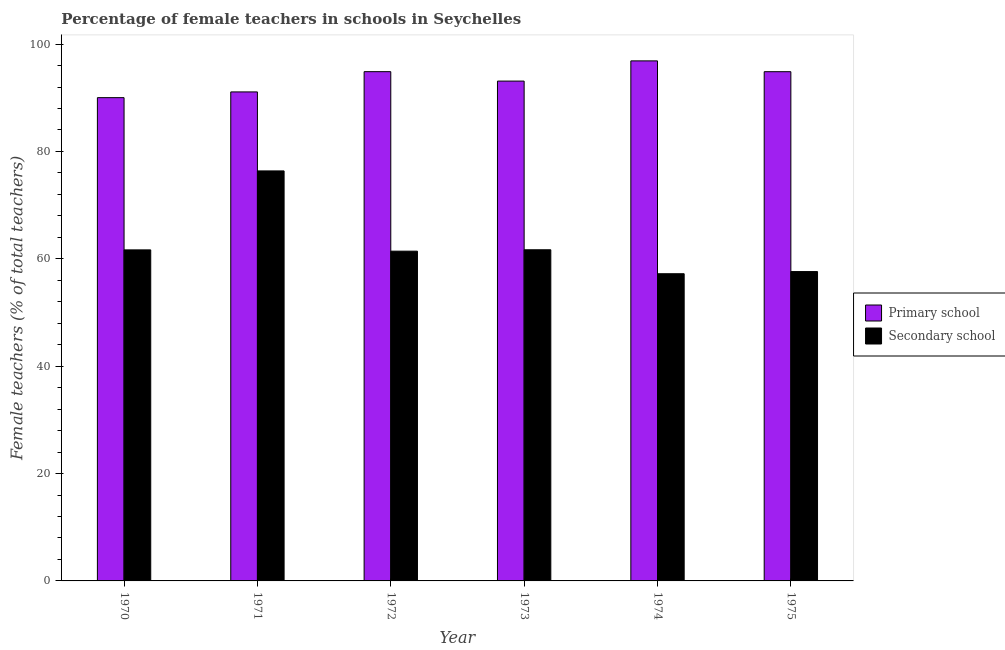How many different coloured bars are there?
Your response must be concise. 2. How many groups of bars are there?
Offer a terse response. 6. Are the number of bars on each tick of the X-axis equal?
Offer a very short reply. Yes. How many bars are there on the 3rd tick from the left?
Provide a succinct answer. 2. How many bars are there on the 2nd tick from the right?
Make the answer very short. 2. In how many cases, is the number of bars for a given year not equal to the number of legend labels?
Offer a terse response. 0. What is the percentage of female teachers in secondary schools in 1973?
Make the answer very short. 61.69. Across all years, what is the maximum percentage of female teachers in primary schools?
Your answer should be very brief. 96.88. Across all years, what is the minimum percentage of female teachers in primary schools?
Your response must be concise. 90.03. In which year was the percentage of female teachers in secondary schools minimum?
Keep it short and to the point. 1974. What is the total percentage of female teachers in secondary schools in the graph?
Provide a succinct answer. 376.01. What is the difference between the percentage of female teachers in secondary schools in 1970 and that in 1974?
Your response must be concise. 4.44. What is the difference between the percentage of female teachers in primary schools in 1975 and the percentage of female teachers in secondary schools in 1970?
Offer a terse response. 4.83. What is the average percentage of female teachers in secondary schools per year?
Give a very brief answer. 62.67. What is the ratio of the percentage of female teachers in secondary schools in 1972 to that in 1974?
Keep it short and to the point. 1.07. Is the difference between the percentage of female teachers in primary schools in 1973 and 1974 greater than the difference between the percentage of female teachers in secondary schools in 1973 and 1974?
Offer a very short reply. No. What is the difference between the highest and the second highest percentage of female teachers in primary schools?
Your answer should be compact. 2.01. What is the difference between the highest and the lowest percentage of female teachers in primary schools?
Make the answer very short. 6.85. What does the 1st bar from the left in 1974 represents?
Give a very brief answer. Primary school. What does the 2nd bar from the right in 1974 represents?
Your answer should be compact. Primary school. How many bars are there?
Your answer should be very brief. 12. How many years are there in the graph?
Offer a very short reply. 6. What is the difference between two consecutive major ticks on the Y-axis?
Make the answer very short. 20. Are the values on the major ticks of Y-axis written in scientific E-notation?
Keep it short and to the point. No. Where does the legend appear in the graph?
Provide a succinct answer. Center right. How are the legend labels stacked?
Give a very brief answer. Vertical. What is the title of the graph?
Make the answer very short. Percentage of female teachers in schools in Seychelles. Does "International Tourists" appear as one of the legend labels in the graph?
Give a very brief answer. No. What is the label or title of the X-axis?
Ensure brevity in your answer.  Year. What is the label or title of the Y-axis?
Provide a succinct answer. Female teachers (% of total teachers). What is the Female teachers (% of total teachers) of Primary school in 1970?
Offer a terse response. 90.03. What is the Female teachers (% of total teachers) in Secondary school in 1970?
Your answer should be compact. 61.67. What is the Female teachers (% of total teachers) of Primary school in 1971?
Provide a short and direct response. 91.09. What is the Female teachers (% of total teachers) of Secondary school in 1971?
Offer a terse response. 76.38. What is the Female teachers (% of total teachers) of Primary school in 1972?
Your answer should be very brief. 94.87. What is the Female teachers (% of total teachers) in Secondary school in 1972?
Keep it short and to the point. 61.43. What is the Female teachers (% of total teachers) of Primary school in 1973?
Give a very brief answer. 93.11. What is the Female teachers (% of total teachers) of Secondary school in 1973?
Keep it short and to the point. 61.69. What is the Female teachers (% of total teachers) in Primary school in 1974?
Provide a short and direct response. 96.88. What is the Female teachers (% of total teachers) of Secondary school in 1974?
Offer a terse response. 57.23. What is the Female teachers (% of total teachers) of Primary school in 1975?
Provide a short and direct response. 94.86. What is the Female teachers (% of total teachers) of Secondary school in 1975?
Your answer should be very brief. 57.63. Across all years, what is the maximum Female teachers (% of total teachers) of Primary school?
Offer a terse response. 96.88. Across all years, what is the maximum Female teachers (% of total teachers) in Secondary school?
Keep it short and to the point. 76.38. Across all years, what is the minimum Female teachers (% of total teachers) in Primary school?
Your answer should be compact. 90.03. Across all years, what is the minimum Female teachers (% of total teachers) in Secondary school?
Give a very brief answer. 57.23. What is the total Female teachers (% of total teachers) of Primary school in the graph?
Your response must be concise. 560.83. What is the total Female teachers (% of total teachers) in Secondary school in the graph?
Offer a terse response. 376.01. What is the difference between the Female teachers (% of total teachers) of Primary school in 1970 and that in 1971?
Your response must be concise. -1.07. What is the difference between the Female teachers (% of total teachers) of Secondary school in 1970 and that in 1971?
Offer a terse response. -14.71. What is the difference between the Female teachers (% of total teachers) of Primary school in 1970 and that in 1972?
Your answer should be compact. -4.84. What is the difference between the Female teachers (% of total teachers) in Secondary school in 1970 and that in 1972?
Your answer should be compact. 0.24. What is the difference between the Female teachers (% of total teachers) of Primary school in 1970 and that in 1973?
Provide a succinct answer. -3.09. What is the difference between the Female teachers (% of total teachers) of Secondary school in 1970 and that in 1973?
Your answer should be very brief. -0.02. What is the difference between the Female teachers (% of total teachers) of Primary school in 1970 and that in 1974?
Keep it short and to the point. -6.85. What is the difference between the Female teachers (% of total teachers) of Secondary school in 1970 and that in 1974?
Provide a succinct answer. 4.44. What is the difference between the Female teachers (% of total teachers) in Primary school in 1970 and that in 1975?
Provide a succinct answer. -4.83. What is the difference between the Female teachers (% of total teachers) in Secondary school in 1970 and that in 1975?
Ensure brevity in your answer.  4.04. What is the difference between the Female teachers (% of total teachers) in Primary school in 1971 and that in 1972?
Provide a succinct answer. -3.77. What is the difference between the Female teachers (% of total teachers) of Secondary school in 1971 and that in 1972?
Your answer should be very brief. 14.95. What is the difference between the Female teachers (% of total teachers) in Primary school in 1971 and that in 1973?
Provide a succinct answer. -2.02. What is the difference between the Female teachers (% of total teachers) of Secondary school in 1971 and that in 1973?
Make the answer very short. 14.69. What is the difference between the Female teachers (% of total teachers) in Primary school in 1971 and that in 1974?
Make the answer very short. -5.78. What is the difference between the Female teachers (% of total teachers) in Secondary school in 1971 and that in 1974?
Keep it short and to the point. 19.15. What is the difference between the Female teachers (% of total teachers) in Primary school in 1971 and that in 1975?
Provide a succinct answer. -3.77. What is the difference between the Female teachers (% of total teachers) in Secondary school in 1971 and that in 1975?
Keep it short and to the point. 18.75. What is the difference between the Female teachers (% of total teachers) of Primary school in 1972 and that in 1973?
Keep it short and to the point. 1.75. What is the difference between the Female teachers (% of total teachers) in Secondary school in 1972 and that in 1973?
Offer a very short reply. -0.26. What is the difference between the Female teachers (% of total teachers) of Primary school in 1972 and that in 1974?
Provide a succinct answer. -2.01. What is the difference between the Female teachers (% of total teachers) of Secondary school in 1972 and that in 1974?
Make the answer very short. 4.2. What is the difference between the Female teachers (% of total teachers) in Primary school in 1972 and that in 1975?
Give a very brief answer. 0.01. What is the difference between the Female teachers (% of total teachers) of Secondary school in 1972 and that in 1975?
Offer a very short reply. 3.8. What is the difference between the Female teachers (% of total teachers) of Primary school in 1973 and that in 1974?
Give a very brief answer. -3.76. What is the difference between the Female teachers (% of total teachers) in Secondary school in 1973 and that in 1974?
Make the answer very short. 4.46. What is the difference between the Female teachers (% of total teachers) in Primary school in 1973 and that in 1975?
Ensure brevity in your answer.  -1.75. What is the difference between the Female teachers (% of total teachers) of Secondary school in 1973 and that in 1975?
Provide a succinct answer. 4.06. What is the difference between the Female teachers (% of total teachers) of Primary school in 1974 and that in 1975?
Offer a terse response. 2.02. What is the difference between the Female teachers (% of total teachers) in Secondary school in 1974 and that in 1975?
Keep it short and to the point. -0.4. What is the difference between the Female teachers (% of total teachers) in Primary school in 1970 and the Female teachers (% of total teachers) in Secondary school in 1971?
Your response must be concise. 13.65. What is the difference between the Female teachers (% of total teachers) of Primary school in 1970 and the Female teachers (% of total teachers) of Secondary school in 1972?
Offer a very short reply. 28.6. What is the difference between the Female teachers (% of total teachers) in Primary school in 1970 and the Female teachers (% of total teachers) in Secondary school in 1973?
Provide a short and direct response. 28.34. What is the difference between the Female teachers (% of total teachers) of Primary school in 1970 and the Female teachers (% of total teachers) of Secondary school in 1974?
Offer a very short reply. 32.8. What is the difference between the Female teachers (% of total teachers) in Primary school in 1970 and the Female teachers (% of total teachers) in Secondary school in 1975?
Give a very brief answer. 32.4. What is the difference between the Female teachers (% of total teachers) in Primary school in 1971 and the Female teachers (% of total teachers) in Secondary school in 1972?
Provide a succinct answer. 29.67. What is the difference between the Female teachers (% of total teachers) of Primary school in 1971 and the Female teachers (% of total teachers) of Secondary school in 1973?
Provide a short and direct response. 29.41. What is the difference between the Female teachers (% of total teachers) in Primary school in 1971 and the Female teachers (% of total teachers) in Secondary school in 1974?
Give a very brief answer. 33.87. What is the difference between the Female teachers (% of total teachers) in Primary school in 1971 and the Female teachers (% of total teachers) in Secondary school in 1975?
Your answer should be very brief. 33.47. What is the difference between the Female teachers (% of total teachers) in Primary school in 1972 and the Female teachers (% of total teachers) in Secondary school in 1973?
Offer a very short reply. 33.18. What is the difference between the Female teachers (% of total teachers) in Primary school in 1972 and the Female teachers (% of total teachers) in Secondary school in 1974?
Offer a very short reply. 37.64. What is the difference between the Female teachers (% of total teachers) of Primary school in 1972 and the Female teachers (% of total teachers) of Secondary school in 1975?
Give a very brief answer. 37.24. What is the difference between the Female teachers (% of total teachers) of Primary school in 1973 and the Female teachers (% of total teachers) of Secondary school in 1974?
Your answer should be compact. 35.89. What is the difference between the Female teachers (% of total teachers) in Primary school in 1973 and the Female teachers (% of total teachers) in Secondary school in 1975?
Ensure brevity in your answer.  35.48. What is the difference between the Female teachers (% of total teachers) of Primary school in 1974 and the Female teachers (% of total teachers) of Secondary school in 1975?
Ensure brevity in your answer.  39.25. What is the average Female teachers (% of total teachers) of Primary school per year?
Give a very brief answer. 93.47. What is the average Female teachers (% of total teachers) in Secondary school per year?
Provide a short and direct response. 62.67. In the year 1970, what is the difference between the Female teachers (% of total teachers) of Primary school and Female teachers (% of total teachers) of Secondary school?
Your response must be concise. 28.36. In the year 1971, what is the difference between the Female teachers (% of total teachers) of Primary school and Female teachers (% of total teachers) of Secondary school?
Offer a terse response. 14.72. In the year 1972, what is the difference between the Female teachers (% of total teachers) in Primary school and Female teachers (% of total teachers) in Secondary school?
Keep it short and to the point. 33.44. In the year 1973, what is the difference between the Female teachers (% of total teachers) in Primary school and Female teachers (% of total teachers) in Secondary school?
Offer a terse response. 31.42. In the year 1974, what is the difference between the Female teachers (% of total teachers) of Primary school and Female teachers (% of total teachers) of Secondary school?
Offer a terse response. 39.65. In the year 1975, what is the difference between the Female teachers (% of total teachers) of Primary school and Female teachers (% of total teachers) of Secondary school?
Provide a short and direct response. 37.23. What is the ratio of the Female teachers (% of total teachers) of Primary school in 1970 to that in 1971?
Make the answer very short. 0.99. What is the ratio of the Female teachers (% of total teachers) of Secondary school in 1970 to that in 1971?
Give a very brief answer. 0.81. What is the ratio of the Female teachers (% of total teachers) of Primary school in 1970 to that in 1972?
Your answer should be compact. 0.95. What is the ratio of the Female teachers (% of total teachers) in Primary school in 1970 to that in 1973?
Offer a very short reply. 0.97. What is the ratio of the Female teachers (% of total teachers) of Secondary school in 1970 to that in 1973?
Your answer should be compact. 1. What is the ratio of the Female teachers (% of total teachers) in Primary school in 1970 to that in 1974?
Give a very brief answer. 0.93. What is the ratio of the Female teachers (% of total teachers) in Secondary school in 1970 to that in 1974?
Give a very brief answer. 1.08. What is the ratio of the Female teachers (% of total teachers) in Primary school in 1970 to that in 1975?
Your answer should be very brief. 0.95. What is the ratio of the Female teachers (% of total teachers) of Secondary school in 1970 to that in 1975?
Your answer should be very brief. 1.07. What is the ratio of the Female teachers (% of total teachers) in Primary school in 1971 to that in 1972?
Provide a short and direct response. 0.96. What is the ratio of the Female teachers (% of total teachers) of Secondary school in 1971 to that in 1972?
Give a very brief answer. 1.24. What is the ratio of the Female teachers (% of total teachers) in Primary school in 1971 to that in 1973?
Offer a very short reply. 0.98. What is the ratio of the Female teachers (% of total teachers) of Secondary school in 1971 to that in 1973?
Keep it short and to the point. 1.24. What is the ratio of the Female teachers (% of total teachers) in Primary school in 1971 to that in 1974?
Give a very brief answer. 0.94. What is the ratio of the Female teachers (% of total teachers) in Secondary school in 1971 to that in 1974?
Make the answer very short. 1.33. What is the ratio of the Female teachers (% of total teachers) of Primary school in 1971 to that in 1975?
Offer a terse response. 0.96. What is the ratio of the Female teachers (% of total teachers) of Secondary school in 1971 to that in 1975?
Your answer should be very brief. 1.33. What is the ratio of the Female teachers (% of total teachers) of Primary school in 1972 to that in 1973?
Offer a very short reply. 1.02. What is the ratio of the Female teachers (% of total teachers) of Primary school in 1972 to that in 1974?
Make the answer very short. 0.98. What is the ratio of the Female teachers (% of total teachers) in Secondary school in 1972 to that in 1974?
Give a very brief answer. 1.07. What is the ratio of the Female teachers (% of total teachers) in Primary school in 1972 to that in 1975?
Give a very brief answer. 1. What is the ratio of the Female teachers (% of total teachers) in Secondary school in 1972 to that in 1975?
Your answer should be compact. 1.07. What is the ratio of the Female teachers (% of total teachers) of Primary school in 1973 to that in 1974?
Give a very brief answer. 0.96. What is the ratio of the Female teachers (% of total teachers) in Secondary school in 1973 to that in 1974?
Make the answer very short. 1.08. What is the ratio of the Female teachers (% of total teachers) in Primary school in 1973 to that in 1975?
Your response must be concise. 0.98. What is the ratio of the Female teachers (% of total teachers) of Secondary school in 1973 to that in 1975?
Give a very brief answer. 1.07. What is the ratio of the Female teachers (% of total teachers) of Primary school in 1974 to that in 1975?
Your answer should be very brief. 1.02. What is the difference between the highest and the second highest Female teachers (% of total teachers) of Primary school?
Keep it short and to the point. 2.01. What is the difference between the highest and the second highest Female teachers (% of total teachers) of Secondary school?
Provide a short and direct response. 14.69. What is the difference between the highest and the lowest Female teachers (% of total teachers) of Primary school?
Provide a succinct answer. 6.85. What is the difference between the highest and the lowest Female teachers (% of total teachers) in Secondary school?
Give a very brief answer. 19.15. 